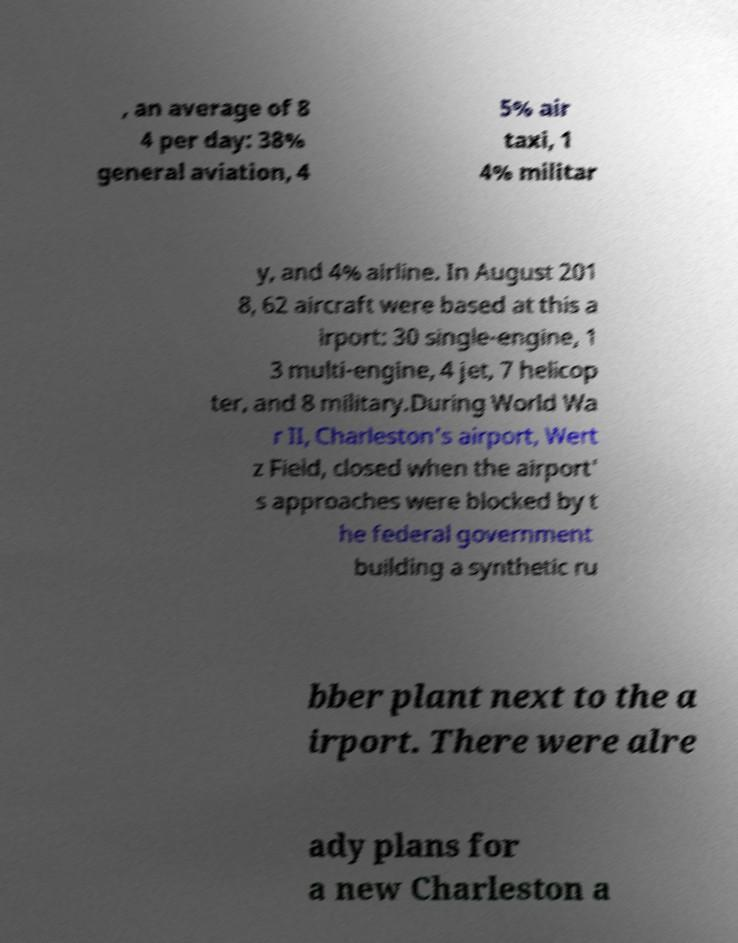Could you assist in decoding the text presented in this image and type it out clearly? , an average of 8 4 per day: 38% general aviation, 4 5% air taxi, 1 4% militar y, and 4% airline. In August 201 8, 62 aircraft were based at this a irport: 30 single-engine, 1 3 multi-engine, 4 jet, 7 helicop ter, and 8 military.During World Wa r II, Charleston's airport, Wert z Field, closed when the airport' s approaches were blocked by t he federal government building a synthetic ru bber plant next to the a irport. There were alre ady plans for a new Charleston a 